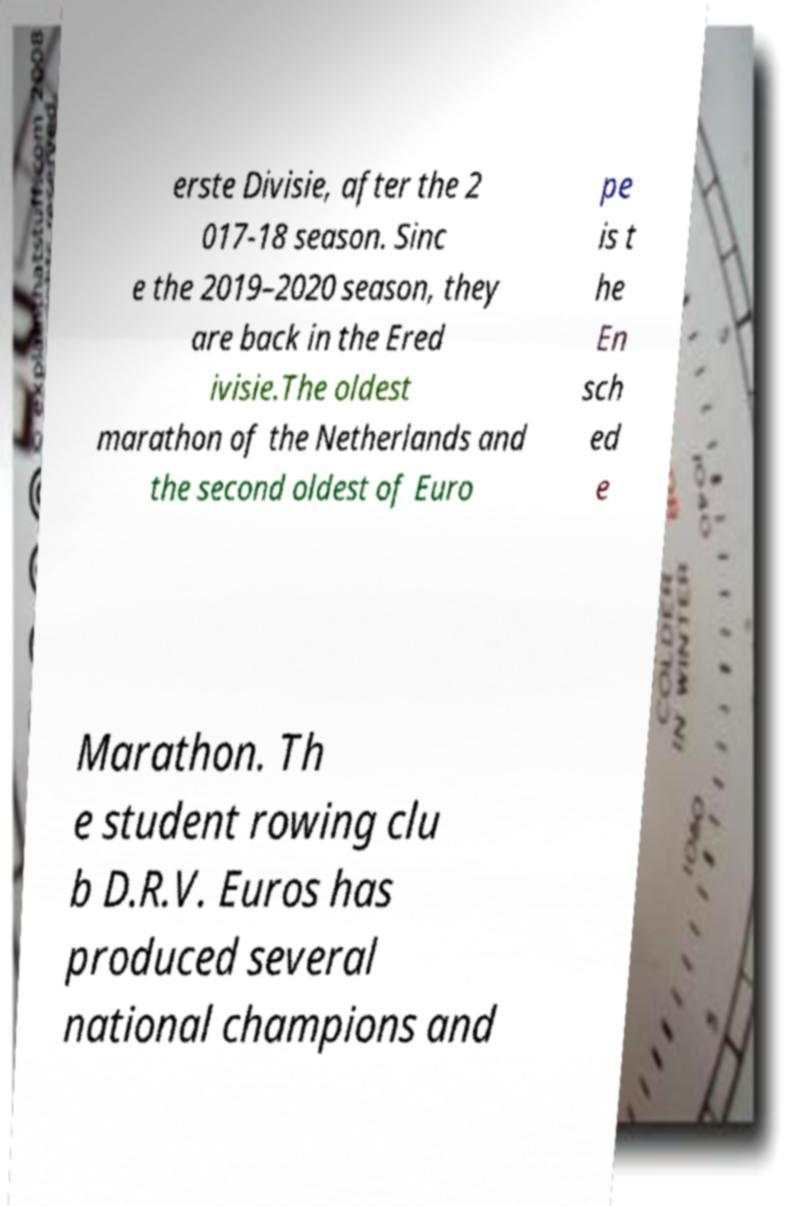Can you read and provide the text displayed in the image?This photo seems to have some interesting text. Can you extract and type it out for me? erste Divisie, after the 2 017-18 season. Sinc e the 2019–2020 season, they are back in the Ered ivisie.The oldest marathon of the Netherlands and the second oldest of Euro pe is t he En sch ed e Marathon. Th e student rowing clu b D.R.V. Euros has produced several national champions and 